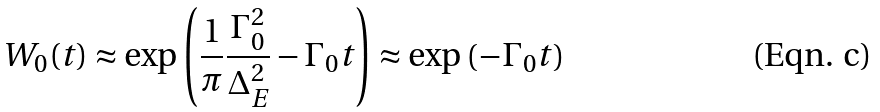<formula> <loc_0><loc_0><loc_500><loc_500>W _ { 0 } ( t ) \approx \exp \left ( \frac { 1 } { \pi } \frac { \Gamma _ { 0 } ^ { 2 } } { \Delta _ { E } ^ { 2 } } - \Gamma _ { 0 } t \right ) \approx \exp \left ( - \Gamma _ { 0 } t \right )</formula> 